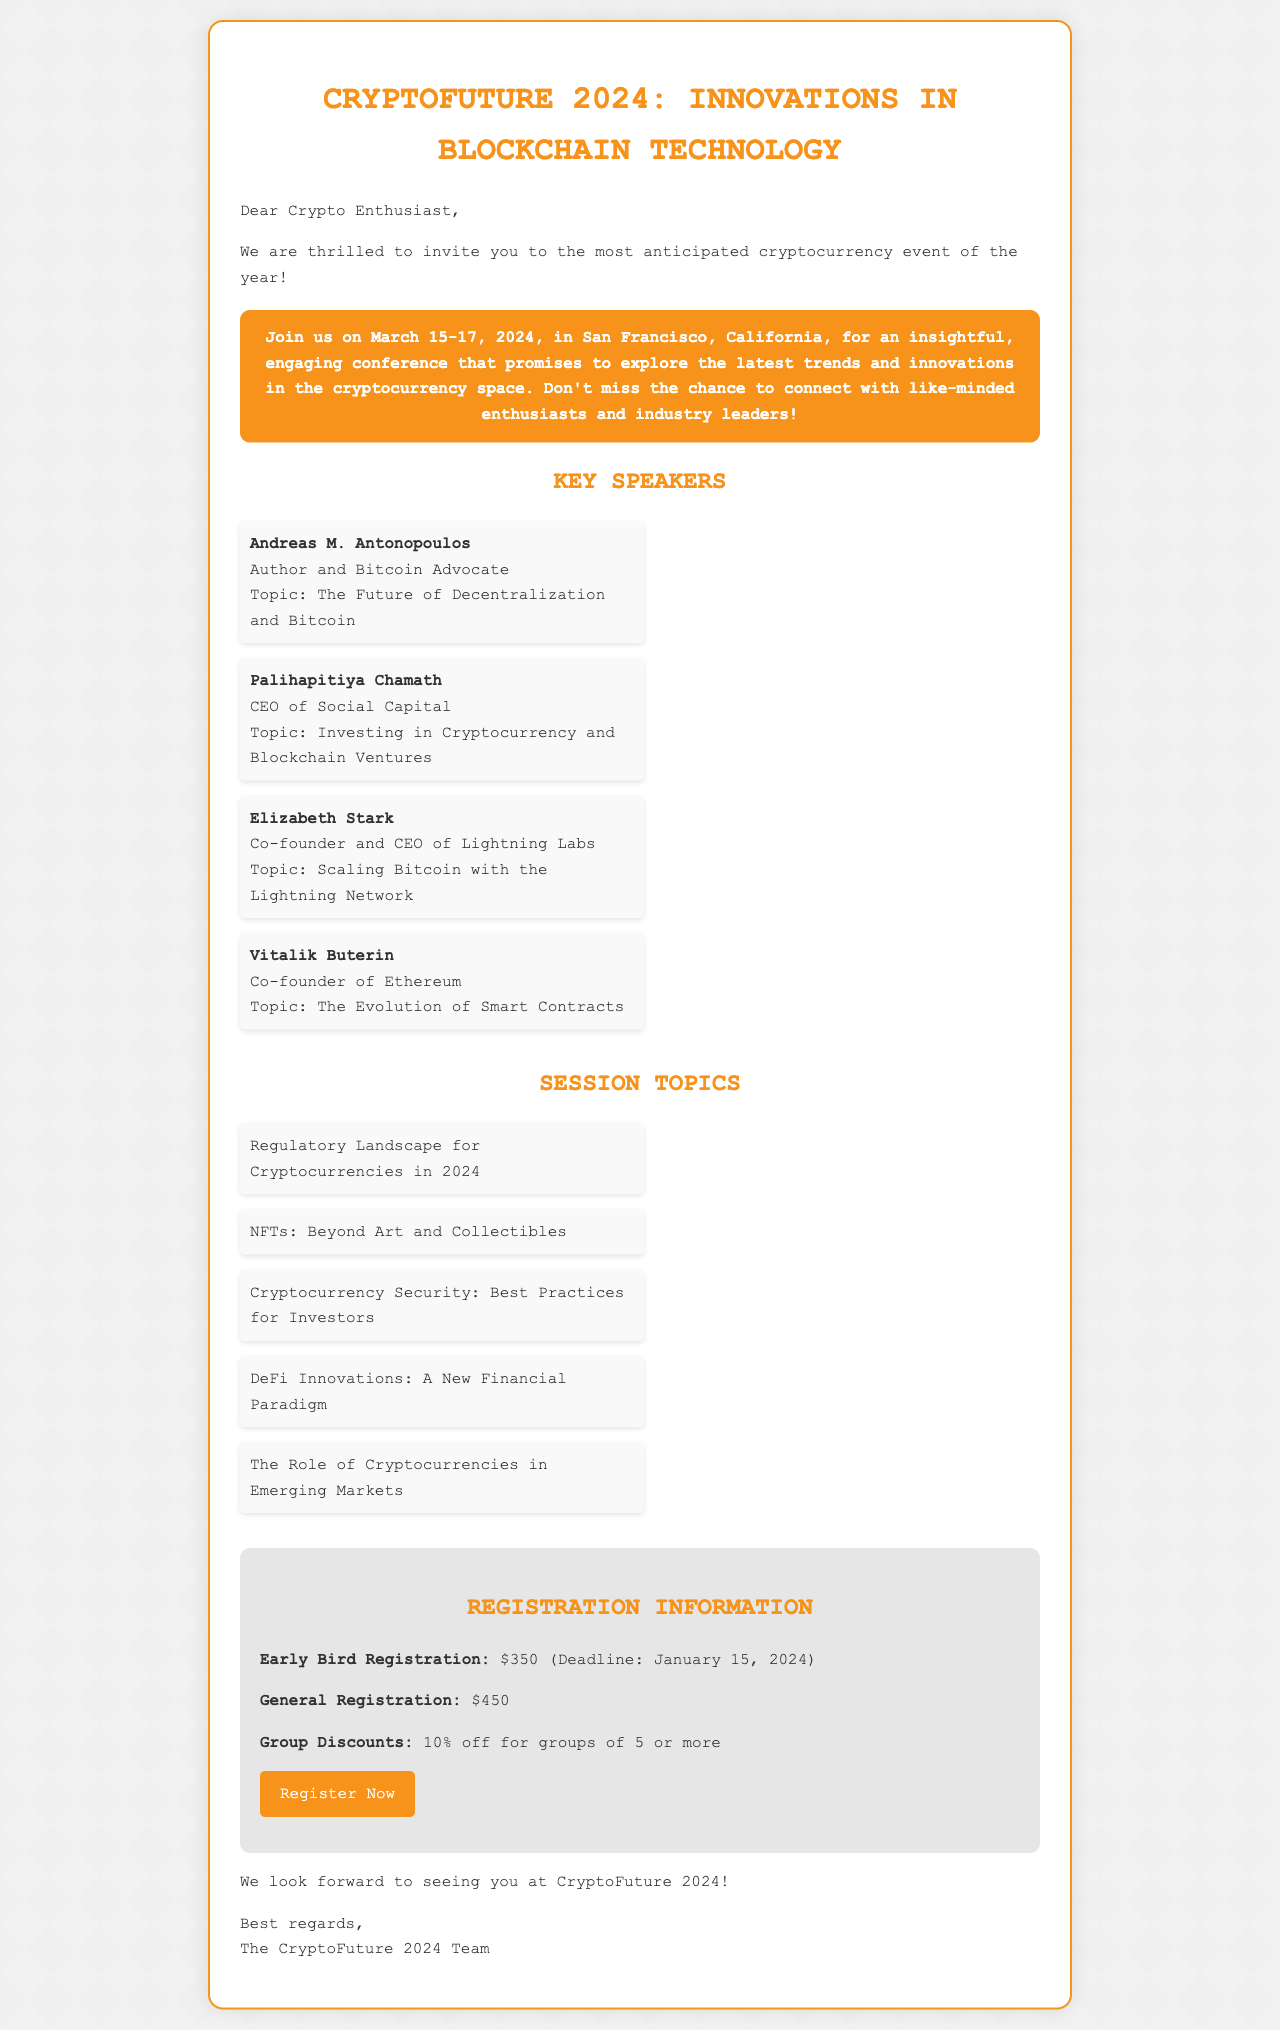What are the dates of the conference? The conference is scheduled for March 15-17, 2024, as stated in the document.
Answer: March 15-17, 2024 Who is speaking about decentralized technology? Andreas M. Antonopoulos is presenting on this topic, as indicated in the list of key speakers.
Answer: Andreas M. Antonopoulos What is the early bird registration fee? The document specifies that early bird registration costs $350.
Answer: $350 What is one topic discussed in the session details? The document lists several session topics, including "Regulatory Landscape for Cryptocurrencies in 2024".
Answer: Regulatory Landscape for Cryptocurrencies in 2024 What is the location of the conference? The document mentions that the conference will take place in San Francisco, California.
Answer: San Francisco, California How much discount is offered for group registrations? The document states a 10% discount for groups of 5 or more attendees.
Answer: 10% off Who is the CEO of Lightning Labs speaking at the conference? The document identifies Elizabeth Stark as the Co-founder and CEO of Lightning Labs.
Answer: Elizabeth Stark What is the registration deadline for early bird pricing? It is mentioned in the document that the early bird registration deadline is January 15, 2024.
Answer: January 15, 2024 What type of event is this document promoting? The document invites readers to a cryptocurrency conference, which is a specific event type.
Answer: Cryptocurrency conference 